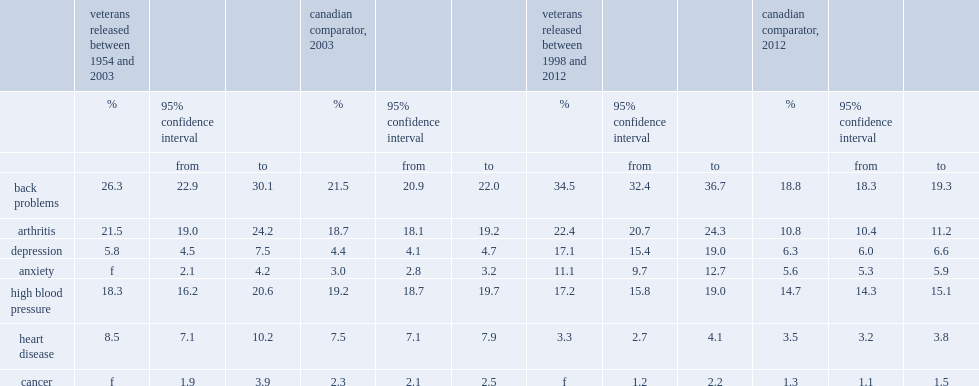Which had a higher prevalence of back problems,veterans of both eras or comparable canadians? Veterans released between 1954 and 2003 veterans released between 1998 and 2012. 